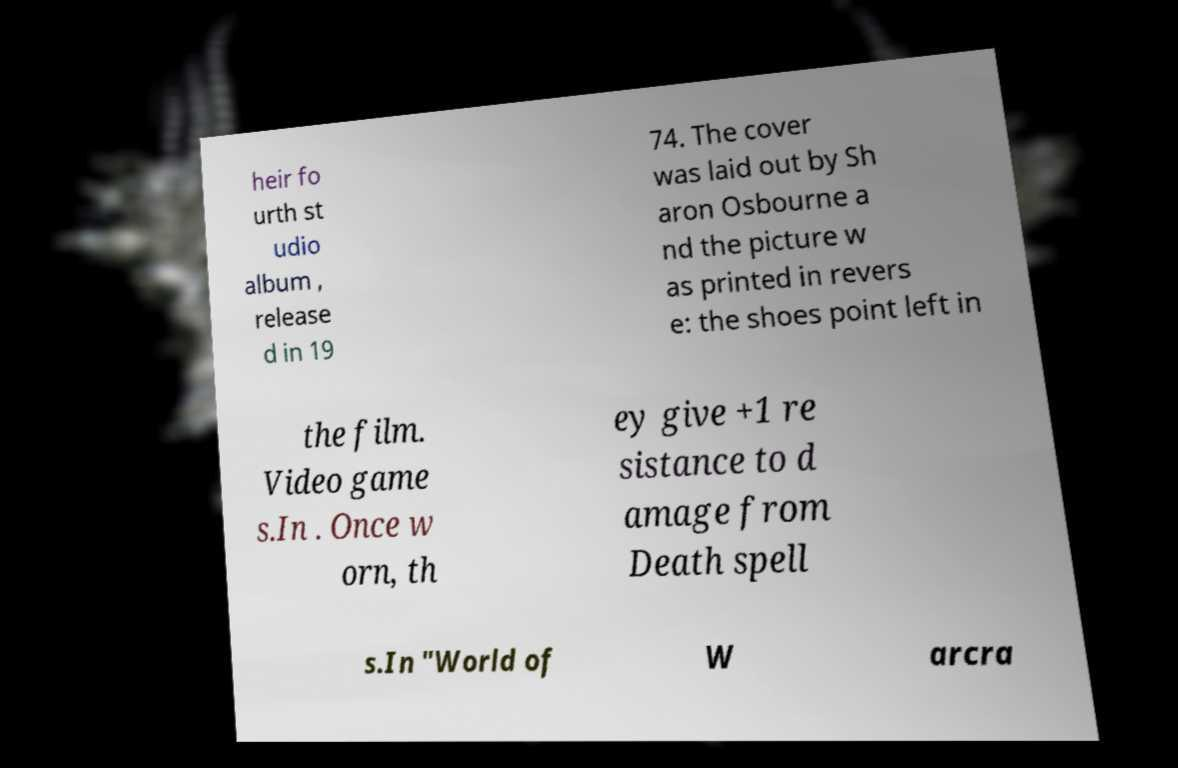Can you accurately transcribe the text from the provided image for me? heir fo urth st udio album , release d in 19 74. The cover was laid out by Sh aron Osbourne a nd the picture w as printed in revers e: the shoes point left in the film. Video game s.In . Once w orn, th ey give +1 re sistance to d amage from Death spell s.In "World of W arcra 